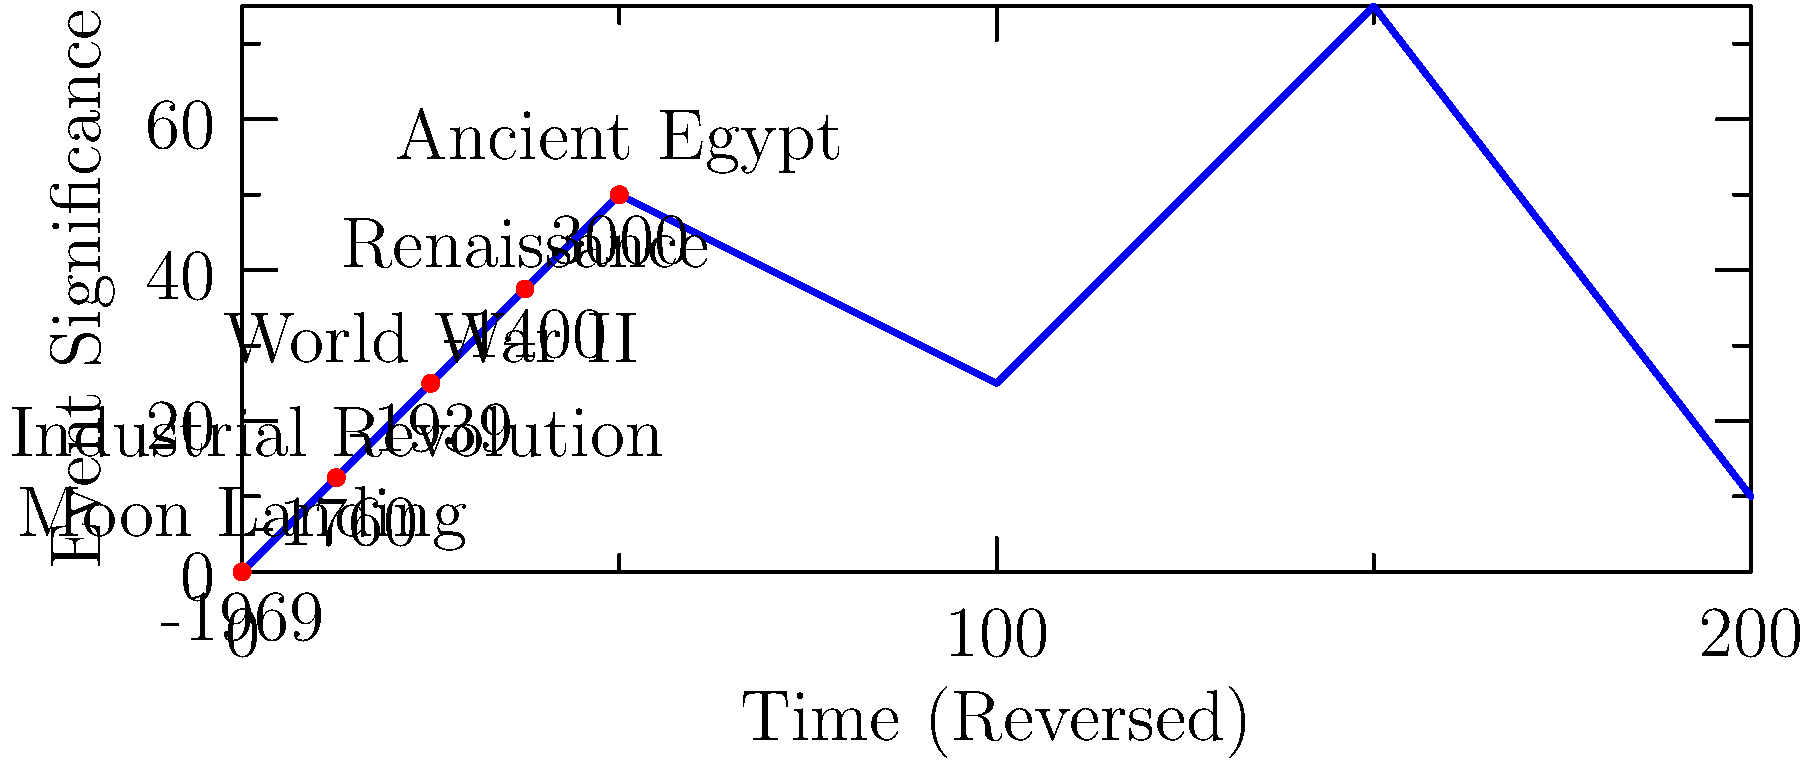Analyze the non-linear timeline depicted in the image. Which historical event appears to be chronologically misplaced according to conventional historical records? To solve this puzzle, we need to examine the events and their corresponding years on the reversed timeline:

1. Ancient Egypt: -3000 (5000 years ago from now)
2. Renaissance: -1400 (3400 years ago from now)
3. World War II: -1939 (3939 years ago from now)
4. Industrial Revolution: -1760 (3760 years ago from now)
5. Moon Landing: -1969 (3969 years ago from now)

Analyzing these events chronologically:
1. Ancient Egypt is correctly placed as the earliest event.
2. The Renaissance is correctly placed after Ancient Egypt.
3. The Industrial Revolution is correctly placed after the Renaissance.
4. World War II is correctly placed after the Industrial Revolution.
5. The Moon Landing should be the most recent event, occurring after World War II.

The Moon Landing (1969) is placed before World War II (1939) on this timeline, which contradicts the conventional chronological order of these events.
Answer: Moon Landing 